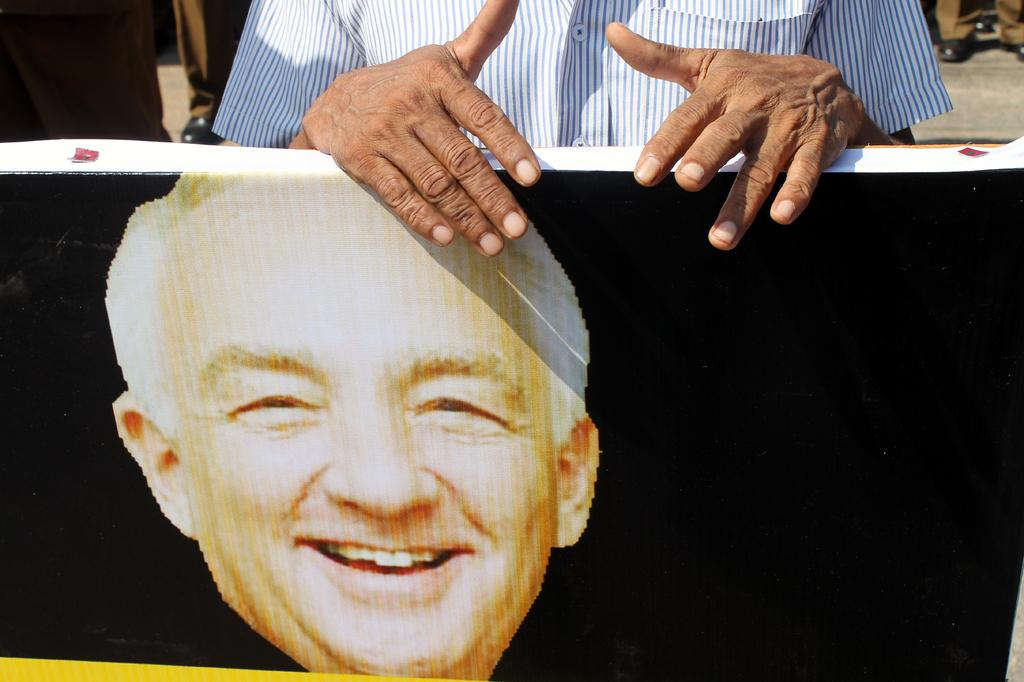What is the man in the image holding? The man in the image is holding a hoarding. What can be seen on the hoarding? The hoarding contains a picture of a man's face. Can you describe the people in the background of the image? There are other people standing in the background of the image. What type of fruit is hanging from the hoarding in the image? There is no fruit hanging from the hoarding in the image; it only contains a picture of a man's face. How many wings are visible on the man holding the hoarding? The man holding the hoarding does not have any visible wings; he is a regular person. 